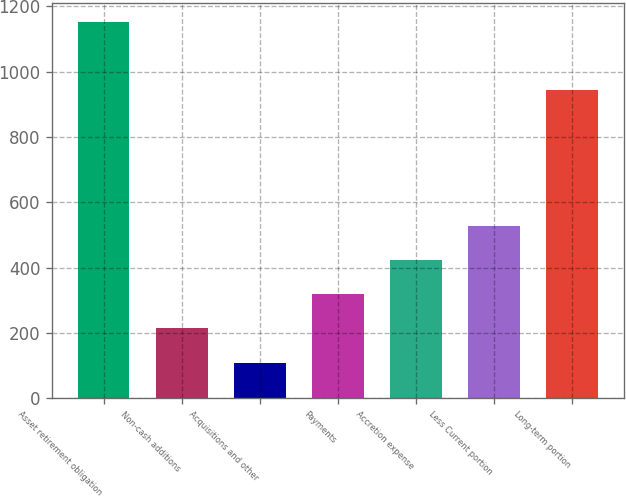<chart> <loc_0><loc_0><loc_500><loc_500><bar_chart><fcel>Asset retirement obligation<fcel>Non-cash additions<fcel>Acquisitions and other<fcel>Payments<fcel>Accretion expense<fcel>Less Current portion<fcel>Long-term portion<nl><fcel>1151.56<fcel>214.16<fcel>109.38<fcel>318.94<fcel>423.72<fcel>528.5<fcel>942<nl></chart> 